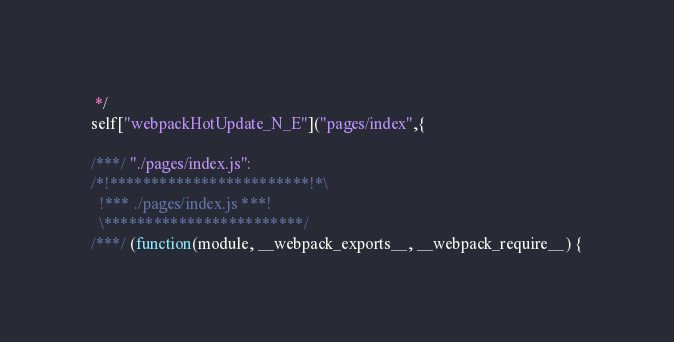Convert code to text. <code><loc_0><loc_0><loc_500><loc_500><_JavaScript_> */
self["webpackHotUpdate_N_E"]("pages/index",{

/***/ "./pages/index.js":
/*!************************!*\
  !*** ./pages/index.js ***!
  \************************/
/***/ (function(module, __webpack_exports__, __webpack_require__) {
</code> 